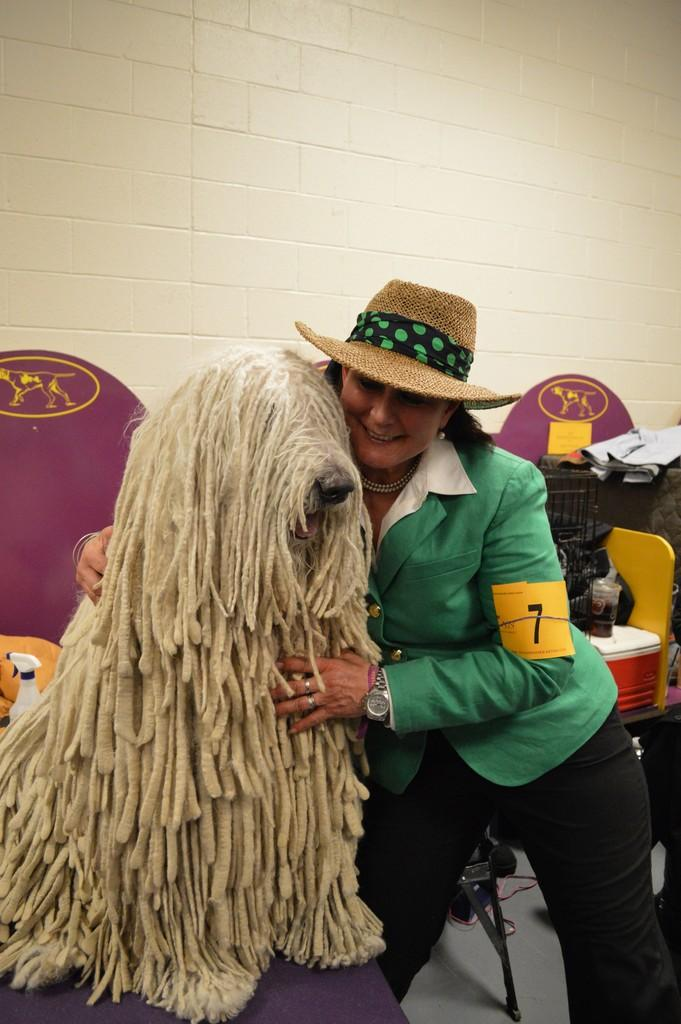What is the main subject of the image? There is a lady person in the image. Can you describe the lady person's attire? The lady person is wearing a green dress. What is the lady person doing in the image? The lady person is hugging a puppy. What type of heart-shaped object can be seen on the lady person's thumb in the image? There is no heart-shaped object on the lady person's thumb in the image. Can you describe the zipper on the lady person's dress in the image? There is no zipper visible on the lady person's dress in the image. 